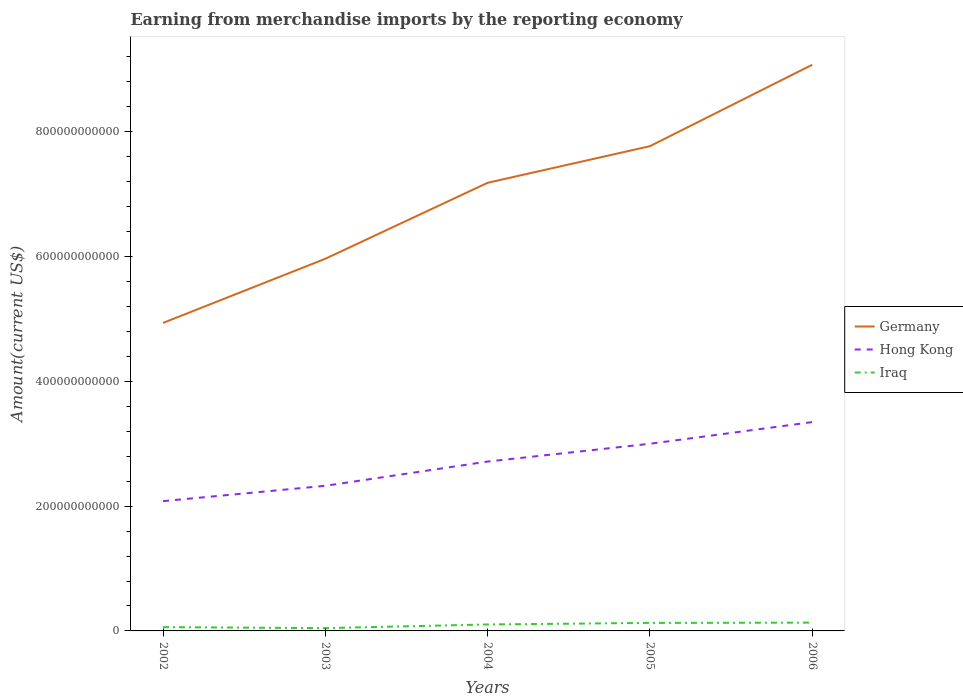How many different coloured lines are there?
Offer a terse response. 3. Is the number of lines equal to the number of legend labels?
Your response must be concise. Yes. Across all years, what is the maximum amount earned from merchandise imports in Iraq?
Keep it short and to the point. 4.49e+09. In which year was the amount earned from merchandise imports in Hong Kong maximum?
Ensure brevity in your answer.  2002. What is the total amount earned from merchandise imports in Germany in the graph?
Make the answer very short. -2.25e+11. What is the difference between the highest and the second highest amount earned from merchandise imports in Germany?
Your answer should be very brief. 4.14e+11. What is the difference between the highest and the lowest amount earned from merchandise imports in Germany?
Provide a short and direct response. 3. How many lines are there?
Offer a terse response. 3. How many years are there in the graph?
Ensure brevity in your answer.  5. What is the difference between two consecutive major ticks on the Y-axis?
Your answer should be compact. 2.00e+11. Does the graph contain grids?
Offer a terse response. No. Where does the legend appear in the graph?
Give a very brief answer. Center right. How many legend labels are there?
Make the answer very short. 3. What is the title of the graph?
Your answer should be compact. Earning from merchandise imports by the reporting economy. What is the label or title of the X-axis?
Give a very brief answer. Years. What is the label or title of the Y-axis?
Offer a very short reply. Amount(current US$). What is the Amount(current US$) in Germany in 2002?
Make the answer very short. 4.94e+11. What is the Amount(current US$) in Hong Kong in 2002?
Your response must be concise. 2.08e+11. What is the Amount(current US$) of Iraq in 2002?
Offer a terse response. 6.08e+09. What is the Amount(current US$) in Germany in 2003?
Make the answer very short. 5.96e+11. What is the Amount(current US$) of Hong Kong in 2003?
Offer a terse response. 2.33e+11. What is the Amount(current US$) of Iraq in 2003?
Your response must be concise. 4.49e+09. What is the Amount(current US$) of Germany in 2004?
Offer a very short reply. 7.18e+11. What is the Amount(current US$) of Hong Kong in 2004?
Your answer should be very brief. 2.71e+11. What is the Amount(current US$) of Iraq in 2004?
Your answer should be compact. 1.03e+1. What is the Amount(current US$) in Germany in 2005?
Offer a very short reply. 7.77e+11. What is the Amount(current US$) in Hong Kong in 2005?
Provide a succinct answer. 3.00e+11. What is the Amount(current US$) in Iraq in 2005?
Keep it short and to the point. 1.28e+1. What is the Amount(current US$) in Germany in 2006?
Your answer should be very brief. 9.07e+11. What is the Amount(current US$) in Hong Kong in 2006?
Your response must be concise. 3.35e+11. What is the Amount(current US$) of Iraq in 2006?
Provide a short and direct response. 1.33e+1. Across all years, what is the maximum Amount(current US$) of Germany?
Keep it short and to the point. 9.07e+11. Across all years, what is the maximum Amount(current US$) of Hong Kong?
Keep it short and to the point. 3.35e+11. Across all years, what is the maximum Amount(current US$) of Iraq?
Make the answer very short. 1.33e+1. Across all years, what is the minimum Amount(current US$) in Germany?
Keep it short and to the point. 4.94e+11. Across all years, what is the minimum Amount(current US$) of Hong Kong?
Make the answer very short. 2.08e+11. Across all years, what is the minimum Amount(current US$) of Iraq?
Make the answer very short. 4.49e+09. What is the total Amount(current US$) in Germany in the graph?
Give a very brief answer. 3.49e+12. What is the total Amount(current US$) of Hong Kong in the graph?
Ensure brevity in your answer.  1.35e+12. What is the total Amount(current US$) of Iraq in the graph?
Your response must be concise. 4.71e+1. What is the difference between the Amount(current US$) of Germany in 2002 and that in 2003?
Ensure brevity in your answer.  -1.03e+11. What is the difference between the Amount(current US$) of Hong Kong in 2002 and that in 2003?
Provide a short and direct response. -2.46e+1. What is the difference between the Amount(current US$) in Iraq in 2002 and that in 2003?
Provide a succinct answer. 1.59e+09. What is the difference between the Amount(current US$) in Germany in 2002 and that in 2004?
Provide a succinct answer. -2.25e+11. What is the difference between the Amount(current US$) of Hong Kong in 2002 and that in 2004?
Your answer should be compact. -6.34e+1. What is the difference between the Amount(current US$) of Iraq in 2002 and that in 2004?
Your answer should be compact. -4.26e+09. What is the difference between the Amount(current US$) in Germany in 2002 and that in 2005?
Your response must be concise. -2.83e+11. What is the difference between the Amount(current US$) in Hong Kong in 2002 and that in 2005?
Give a very brief answer. -9.19e+1. What is the difference between the Amount(current US$) of Iraq in 2002 and that in 2005?
Keep it short and to the point. -6.76e+09. What is the difference between the Amount(current US$) of Germany in 2002 and that in 2006?
Your response must be concise. -4.14e+11. What is the difference between the Amount(current US$) of Hong Kong in 2002 and that in 2006?
Your answer should be very brief. -1.27e+11. What is the difference between the Amount(current US$) of Iraq in 2002 and that in 2006?
Offer a very short reply. -7.22e+09. What is the difference between the Amount(current US$) of Germany in 2003 and that in 2004?
Your answer should be compact. -1.22e+11. What is the difference between the Amount(current US$) of Hong Kong in 2003 and that in 2004?
Offer a terse response. -3.89e+1. What is the difference between the Amount(current US$) of Iraq in 2003 and that in 2004?
Offer a terse response. -5.85e+09. What is the difference between the Amount(current US$) of Germany in 2003 and that in 2005?
Make the answer very short. -1.80e+11. What is the difference between the Amount(current US$) in Hong Kong in 2003 and that in 2005?
Your response must be concise. -6.74e+1. What is the difference between the Amount(current US$) in Iraq in 2003 and that in 2005?
Offer a very short reply. -8.35e+09. What is the difference between the Amount(current US$) in Germany in 2003 and that in 2006?
Your answer should be very brief. -3.11e+11. What is the difference between the Amount(current US$) in Hong Kong in 2003 and that in 2006?
Your answer should be very brief. -1.02e+11. What is the difference between the Amount(current US$) in Iraq in 2003 and that in 2006?
Make the answer very short. -8.81e+09. What is the difference between the Amount(current US$) in Germany in 2004 and that in 2005?
Give a very brief answer. -5.87e+1. What is the difference between the Amount(current US$) of Hong Kong in 2004 and that in 2005?
Offer a very short reply. -2.85e+1. What is the difference between the Amount(current US$) of Iraq in 2004 and that in 2005?
Make the answer very short. -2.50e+09. What is the difference between the Amount(current US$) in Germany in 2004 and that in 2006?
Give a very brief answer. -1.89e+11. What is the difference between the Amount(current US$) of Hong Kong in 2004 and that in 2006?
Your response must be concise. -6.32e+1. What is the difference between the Amount(current US$) in Iraq in 2004 and that in 2006?
Offer a terse response. -2.96e+09. What is the difference between the Amount(current US$) in Germany in 2005 and that in 2006?
Your response must be concise. -1.31e+11. What is the difference between the Amount(current US$) of Hong Kong in 2005 and that in 2006?
Offer a terse response. -3.47e+1. What is the difference between the Amount(current US$) of Iraq in 2005 and that in 2006?
Ensure brevity in your answer.  -4.61e+08. What is the difference between the Amount(current US$) in Germany in 2002 and the Amount(current US$) in Hong Kong in 2003?
Make the answer very short. 2.61e+11. What is the difference between the Amount(current US$) of Germany in 2002 and the Amount(current US$) of Iraq in 2003?
Provide a short and direct response. 4.89e+11. What is the difference between the Amount(current US$) of Hong Kong in 2002 and the Amount(current US$) of Iraq in 2003?
Make the answer very short. 2.04e+11. What is the difference between the Amount(current US$) in Germany in 2002 and the Amount(current US$) in Hong Kong in 2004?
Provide a short and direct response. 2.22e+11. What is the difference between the Amount(current US$) of Germany in 2002 and the Amount(current US$) of Iraq in 2004?
Keep it short and to the point. 4.83e+11. What is the difference between the Amount(current US$) of Hong Kong in 2002 and the Amount(current US$) of Iraq in 2004?
Keep it short and to the point. 1.98e+11. What is the difference between the Amount(current US$) of Germany in 2002 and the Amount(current US$) of Hong Kong in 2005?
Make the answer very short. 1.94e+11. What is the difference between the Amount(current US$) of Germany in 2002 and the Amount(current US$) of Iraq in 2005?
Give a very brief answer. 4.81e+11. What is the difference between the Amount(current US$) in Hong Kong in 2002 and the Amount(current US$) in Iraq in 2005?
Make the answer very short. 1.95e+11. What is the difference between the Amount(current US$) in Germany in 2002 and the Amount(current US$) in Hong Kong in 2006?
Make the answer very short. 1.59e+11. What is the difference between the Amount(current US$) of Germany in 2002 and the Amount(current US$) of Iraq in 2006?
Provide a succinct answer. 4.80e+11. What is the difference between the Amount(current US$) of Hong Kong in 2002 and the Amount(current US$) of Iraq in 2006?
Your response must be concise. 1.95e+11. What is the difference between the Amount(current US$) of Germany in 2003 and the Amount(current US$) of Hong Kong in 2004?
Offer a terse response. 3.25e+11. What is the difference between the Amount(current US$) in Germany in 2003 and the Amount(current US$) in Iraq in 2004?
Provide a succinct answer. 5.86e+11. What is the difference between the Amount(current US$) in Hong Kong in 2003 and the Amount(current US$) in Iraq in 2004?
Your answer should be very brief. 2.22e+11. What is the difference between the Amount(current US$) in Germany in 2003 and the Amount(current US$) in Hong Kong in 2005?
Provide a short and direct response. 2.97e+11. What is the difference between the Amount(current US$) of Germany in 2003 and the Amount(current US$) of Iraq in 2005?
Keep it short and to the point. 5.84e+11. What is the difference between the Amount(current US$) in Hong Kong in 2003 and the Amount(current US$) in Iraq in 2005?
Your response must be concise. 2.20e+11. What is the difference between the Amount(current US$) of Germany in 2003 and the Amount(current US$) of Hong Kong in 2006?
Your response must be concise. 2.62e+11. What is the difference between the Amount(current US$) in Germany in 2003 and the Amount(current US$) in Iraq in 2006?
Offer a terse response. 5.83e+11. What is the difference between the Amount(current US$) in Hong Kong in 2003 and the Amount(current US$) in Iraq in 2006?
Your answer should be compact. 2.19e+11. What is the difference between the Amount(current US$) in Germany in 2004 and the Amount(current US$) in Hong Kong in 2005?
Offer a terse response. 4.18e+11. What is the difference between the Amount(current US$) of Germany in 2004 and the Amount(current US$) of Iraq in 2005?
Give a very brief answer. 7.05e+11. What is the difference between the Amount(current US$) in Hong Kong in 2004 and the Amount(current US$) in Iraq in 2005?
Your answer should be very brief. 2.59e+11. What is the difference between the Amount(current US$) of Germany in 2004 and the Amount(current US$) of Hong Kong in 2006?
Make the answer very short. 3.84e+11. What is the difference between the Amount(current US$) in Germany in 2004 and the Amount(current US$) in Iraq in 2006?
Your answer should be very brief. 7.05e+11. What is the difference between the Amount(current US$) of Hong Kong in 2004 and the Amount(current US$) of Iraq in 2006?
Give a very brief answer. 2.58e+11. What is the difference between the Amount(current US$) in Germany in 2005 and the Amount(current US$) in Hong Kong in 2006?
Provide a succinct answer. 4.42e+11. What is the difference between the Amount(current US$) in Germany in 2005 and the Amount(current US$) in Iraq in 2006?
Keep it short and to the point. 7.64e+11. What is the difference between the Amount(current US$) in Hong Kong in 2005 and the Amount(current US$) in Iraq in 2006?
Ensure brevity in your answer.  2.87e+11. What is the average Amount(current US$) of Germany per year?
Your answer should be compact. 6.99e+11. What is the average Amount(current US$) of Hong Kong per year?
Your answer should be very brief. 2.69e+11. What is the average Amount(current US$) of Iraq per year?
Your answer should be compact. 9.41e+09. In the year 2002, what is the difference between the Amount(current US$) of Germany and Amount(current US$) of Hong Kong?
Give a very brief answer. 2.86e+11. In the year 2002, what is the difference between the Amount(current US$) of Germany and Amount(current US$) of Iraq?
Your answer should be very brief. 4.88e+11. In the year 2002, what is the difference between the Amount(current US$) of Hong Kong and Amount(current US$) of Iraq?
Your answer should be compact. 2.02e+11. In the year 2003, what is the difference between the Amount(current US$) of Germany and Amount(current US$) of Hong Kong?
Give a very brief answer. 3.64e+11. In the year 2003, what is the difference between the Amount(current US$) in Germany and Amount(current US$) in Iraq?
Provide a succinct answer. 5.92e+11. In the year 2003, what is the difference between the Amount(current US$) in Hong Kong and Amount(current US$) in Iraq?
Give a very brief answer. 2.28e+11. In the year 2004, what is the difference between the Amount(current US$) in Germany and Amount(current US$) in Hong Kong?
Keep it short and to the point. 4.47e+11. In the year 2004, what is the difference between the Amount(current US$) in Germany and Amount(current US$) in Iraq?
Your answer should be very brief. 7.08e+11. In the year 2004, what is the difference between the Amount(current US$) of Hong Kong and Amount(current US$) of Iraq?
Give a very brief answer. 2.61e+11. In the year 2005, what is the difference between the Amount(current US$) of Germany and Amount(current US$) of Hong Kong?
Your response must be concise. 4.77e+11. In the year 2005, what is the difference between the Amount(current US$) in Germany and Amount(current US$) in Iraq?
Make the answer very short. 7.64e+11. In the year 2005, what is the difference between the Amount(current US$) of Hong Kong and Amount(current US$) of Iraq?
Ensure brevity in your answer.  2.87e+11. In the year 2006, what is the difference between the Amount(current US$) of Germany and Amount(current US$) of Hong Kong?
Give a very brief answer. 5.73e+11. In the year 2006, what is the difference between the Amount(current US$) of Germany and Amount(current US$) of Iraq?
Keep it short and to the point. 8.94e+11. In the year 2006, what is the difference between the Amount(current US$) of Hong Kong and Amount(current US$) of Iraq?
Your answer should be compact. 3.21e+11. What is the ratio of the Amount(current US$) in Germany in 2002 to that in 2003?
Make the answer very short. 0.83. What is the ratio of the Amount(current US$) of Hong Kong in 2002 to that in 2003?
Ensure brevity in your answer.  0.89. What is the ratio of the Amount(current US$) of Iraq in 2002 to that in 2003?
Your response must be concise. 1.35. What is the ratio of the Amount(current US$) in Germany in 2002 to that in 2004?
Provide a succinct answer. 0.69. What is the ratio of the Amount(current US$) of Hong Kong in 2002 to that in 2004?
Offer a very short reply. 0.77. What is the ratio of the Amount(current US$) in Iraq in 2002 to that in 2004?
Offer a terse response. 0.59. What is the ratio of the Amount(current US$) of Germany in 2002 to that in 2005?
Keep it short and to the point. 0.64. What is the ratio of the Amount(current US$) in Hong Kong in 2002 to that in 2005?
Make the answer very short. 0.69. What is the ratio of the Amount(current US$) of Iraq in 2002 to that in 2005?
Your response must be concise. 0.47. What is the ratio of the Amount(current US$) of Germany in 2002 to that in 2006?
Your response must be concise. 0.54. What is the ratio of the Amount(current US$) in Hong Kong in 2002 to that in 2006?
Offer a very short reply. 0.62. What is the ratio of the Amount(current US$) of Iraq in 2002 to that in 2006?
Ensure brevity in your answer.  0.46. What is the ratio of the Amount(current US$) of Germany in 2003 to that in 2004?
Keep it short and to the point. 0.83. What is the ratio of the Amount(current US$) in Hong Kong in 2003 to that in 2004?
Your answer should be very brief. 0.86. What is the ratio of the Amount(current US$) in Iraq in 2003 to that in 2004?
Offer a very short reply. 0.43. What is the ratio of the Amount(current US$) of Germany in 2003 to that in 2005?
Provide a short and direct response. 0.77. What is the ratio of the Amount(current US$) in Hong Kong in 2003 to that in 2005?
Offer a very short reply. 0.78. What is the ratio of the Amount(current US$) in Iraq in 2003 to that in 2005?
Make the answer very short. 0.35. What is the ratio of the Amount(current US$) in Germany in 2003 to that in 2006?
Give a very brief answer. 0.66. What is the ratio of the Amount(current US$) of Hong Kong in 2003 to that in 2006?
Offer a terse response. 0.69. What is the ratio of the Amount(current US$) in Iraq in 2003 to that in 2006?
Ensure brevity in your answer.  0.34. What is the ratio of the Amount(current US$) in Germany in 2004 to that in 2005?
Your answer should be very brief. 0.92. What is the ratio of the Amount(current US$) in Hong Kong in 2004 to that in 2005?
Give a very brief answer. 0.91. What is the ratio of the Amount(current US$) in Iraq in 2004 to that in 2005?
Ensure brevity in your answer.  0.81. What is the ratio of the Amount(current US$) of Germany in 2004 to that in 2006?
Offer a terse response. 0.79. What is the ratio of the Amount(current US$) of Hong Kong in 2004 to that in 2006?
Make the answer very short. 0.81. What is the ratio of the Amount(current US$) in Iraq in 2004 to that in 2006?
Provide a succinct answer. 0.78. What is the ratio of the Amount(current US$) in Germany in 2005 to that in 2006?
Give a very brief answer. 0.86. What is the ratio of the Amount(current US$) in Hong Kong in 2005 to that in 2006?
Provide a succinct answer. 0.9. What is the ratio of the Amount(current US$) in Iraq in 2005 to that in 2006?
Your response must be concise. 0.97. What is the difference between the highest and the second highest Amount(current US$) in Germany?
Give a very brief answer. 1.31e+11. What is the difference between the highest and the second highest Amount(current US$) of Hong Kong?
Provide a short and direct response. 3.47e+1. What is the difference between the highest and the second highest Amount(current US$) of Iraq?
Provide a succinct answer. 4.61e+08. What is the difference between the highest and the lowest Amount(current US$) in Germany?
Your answer should be compact. 4.14e+11. What is the difference between the highest and the lowest Amount(current US$) in Hong Kong?
Provide a succinct answer. 1.27e+11. What is the difference between the highest and the lowest Amount(current US$) of Iraq?
Your answer should be compact. 8.81e+09. 